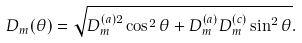<formula> <loc_0><loc_0><loc_500><loc_500>D _ { m } ( \theta ) = \sqrt { D ^ { ( a ) 2 } _ { m } \cos ^ { 2 } \theta + D ^ { ( a ) } _ { m } D ^ { ( c ) } _ { m } \sin ^ { 2 } \theta } .</formula> 